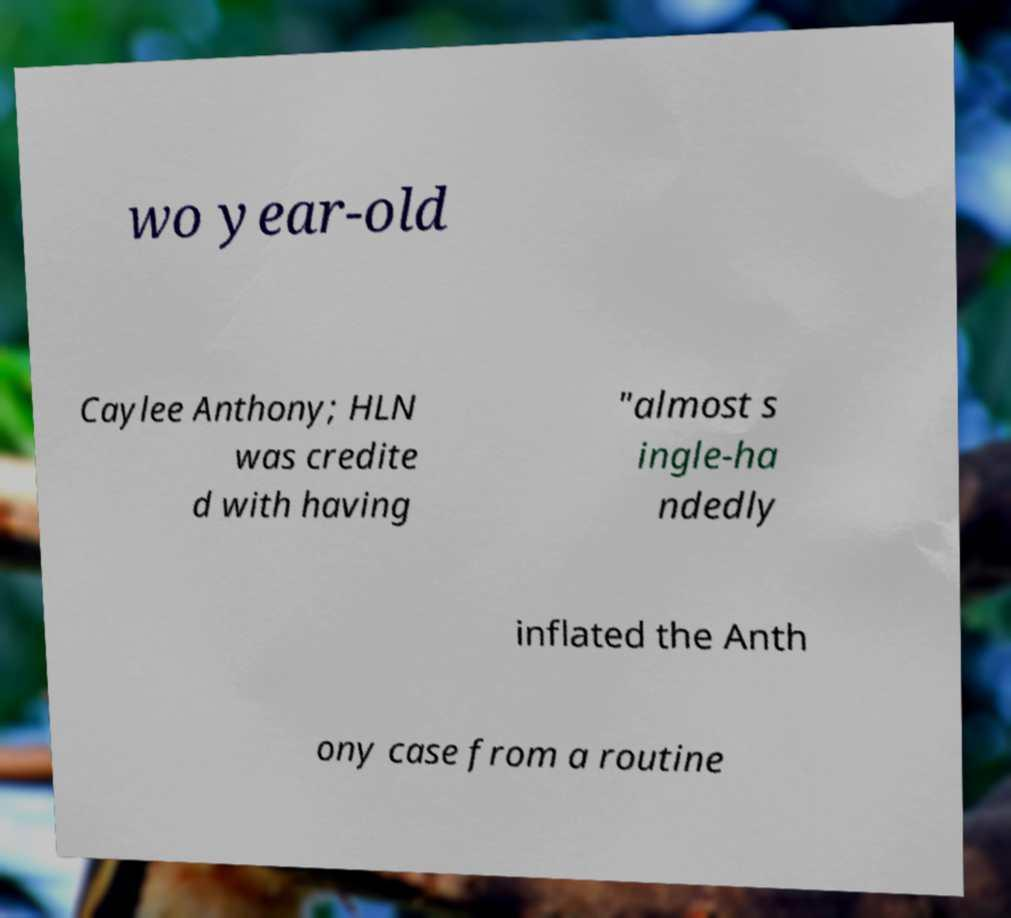Could you assist in decoding the text presented in this image and type it out clearly? wo year-old Caylee Anthony; HLN was credite d with having "almost s ingle-ha ndedly inflated the Anth ony case from a routine 